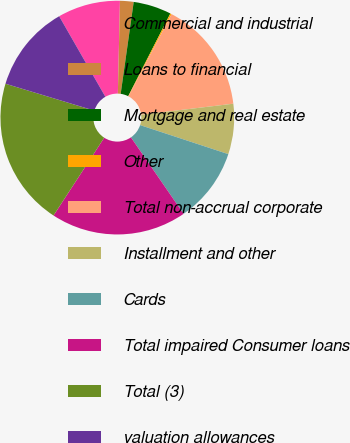Convert chart. <chart><loc_0><loc_0><loc_500><loc_500><pie_chart><fcel>Commercial and industrial<fcel>Loans to financial<fcel>Mortgage and real estate<fcel>Other<fcel>Total non-accrual corporate<fcel>Installment and other<fcel>Cards<fcel>Total impaired Consumer loans<fcel>Total (3)<fcel>valuation allowances<nl><fcel>8.65%<fcel>1.88%<fcel>5.26%<fcel>0.19%<fcel>15.41%<fcel>6.96%<fcel>10.34%<fcel>18.79%<fcel>20.49%<fcel>12.03%<nl></chart> 